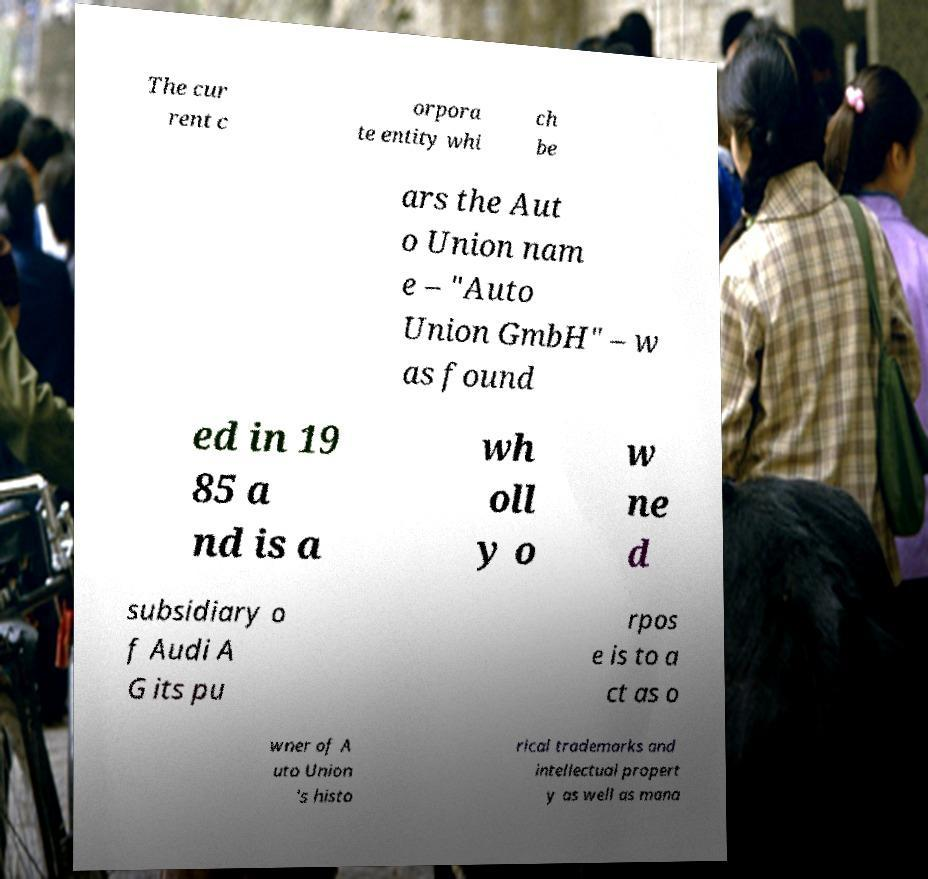Can you read and provide the text displayed in the image?This photo seems to have some interesting text. Can you extract and type it out for me? The cur rent c orpora te entity whi ch be ars the Aut o Union nam e – "Auto Union GmbH" – w as found ed in 19 85 a nd is a wh oll y o w ne d subsidiary o f Audi A G its pu rpos e is to a ct as o wner of A uto Union 's histo rical trademarks and intellectual propert y as well as mana 